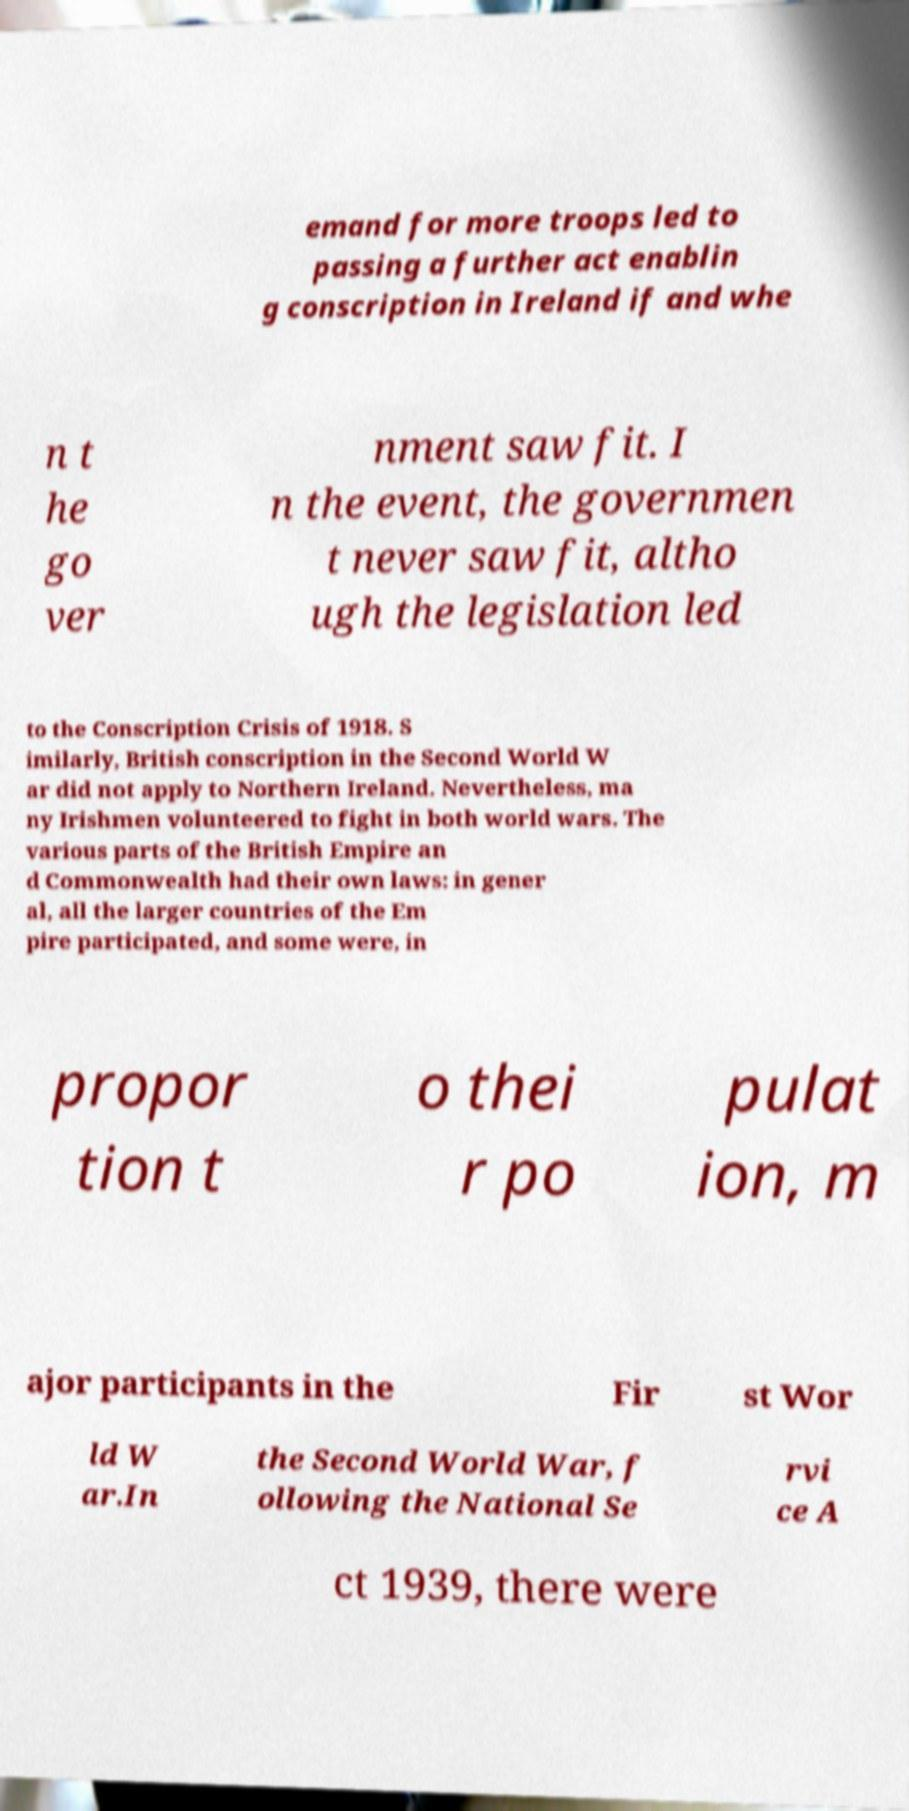Can you accurately transcribe the text from the provided image for me? emand for more troops led to passing a further act enablin g conscription in Ireland if and whe n t he go ver nment saw fit. I n the event, the governmen t never saw fit, altho ugh the legislation led to the Conscription Crisis of 1918. S imilarly, British conscription in the Second World W ar did not apply to Northern Ireland. Nevertheless, ma ny Irishmen volunteered to fight in both world wars. The various parts of the British Empire an d Commonwealth had their own laws: in gener al, all the larger countries of the Em pire participated, and some were, in propor tion t o thei r po pulat ion, m ajor participants in the Fir st Wor ld W ar.In the Second World War, f ollowing the National Se rvi ce A ct 1939, there were 